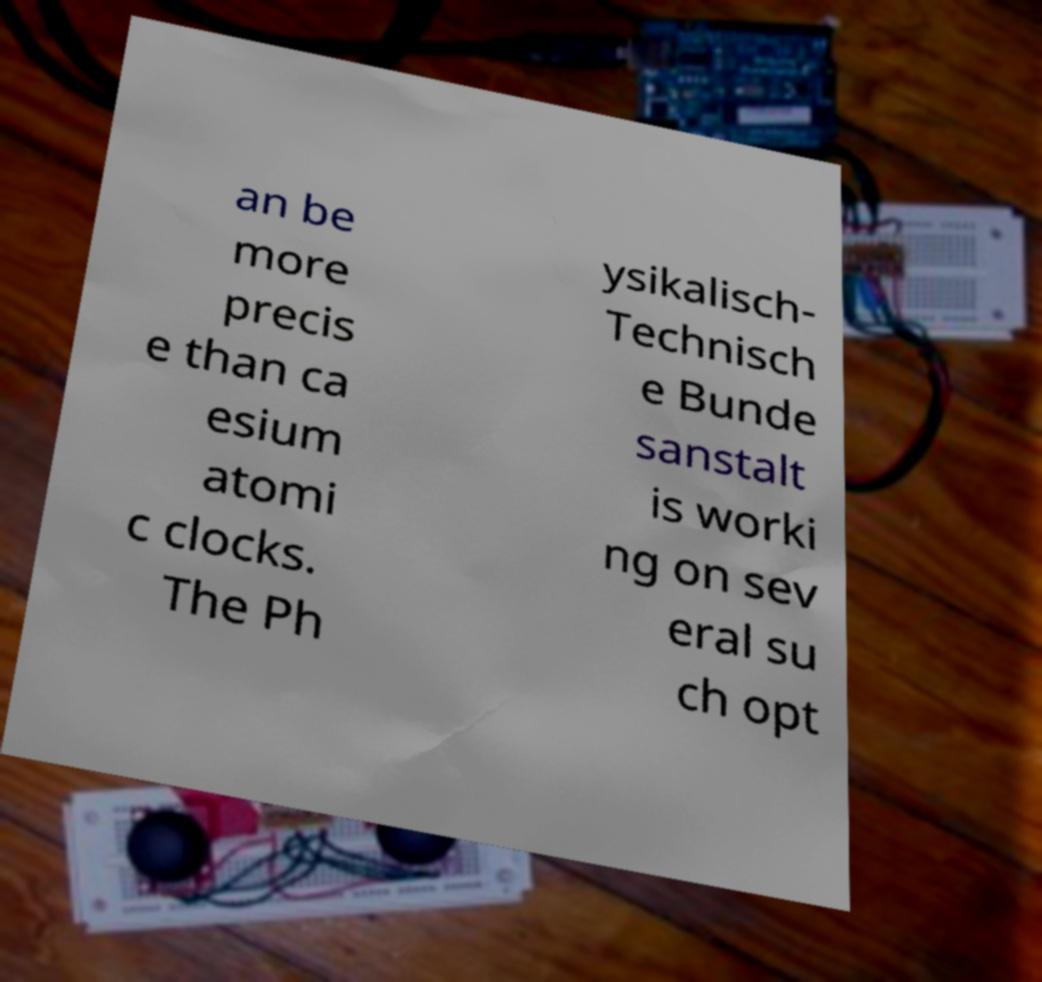Please read and relay the text visible in this image. What does it say? an be more precis e than ca esium atomi c clocks. The Ph ysikalisch- Technisch e Bunde sanstalt is worki ng on sev eral su ch opt 